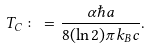Convert formula to latex. <formula><loc_0><loc_0><loc_500><loc_500>T _ { C } \colon = \frac { \alpha \hbar { a } } { 8 ( \ln 2 ) \pi k _ { B } c } .</formula> 